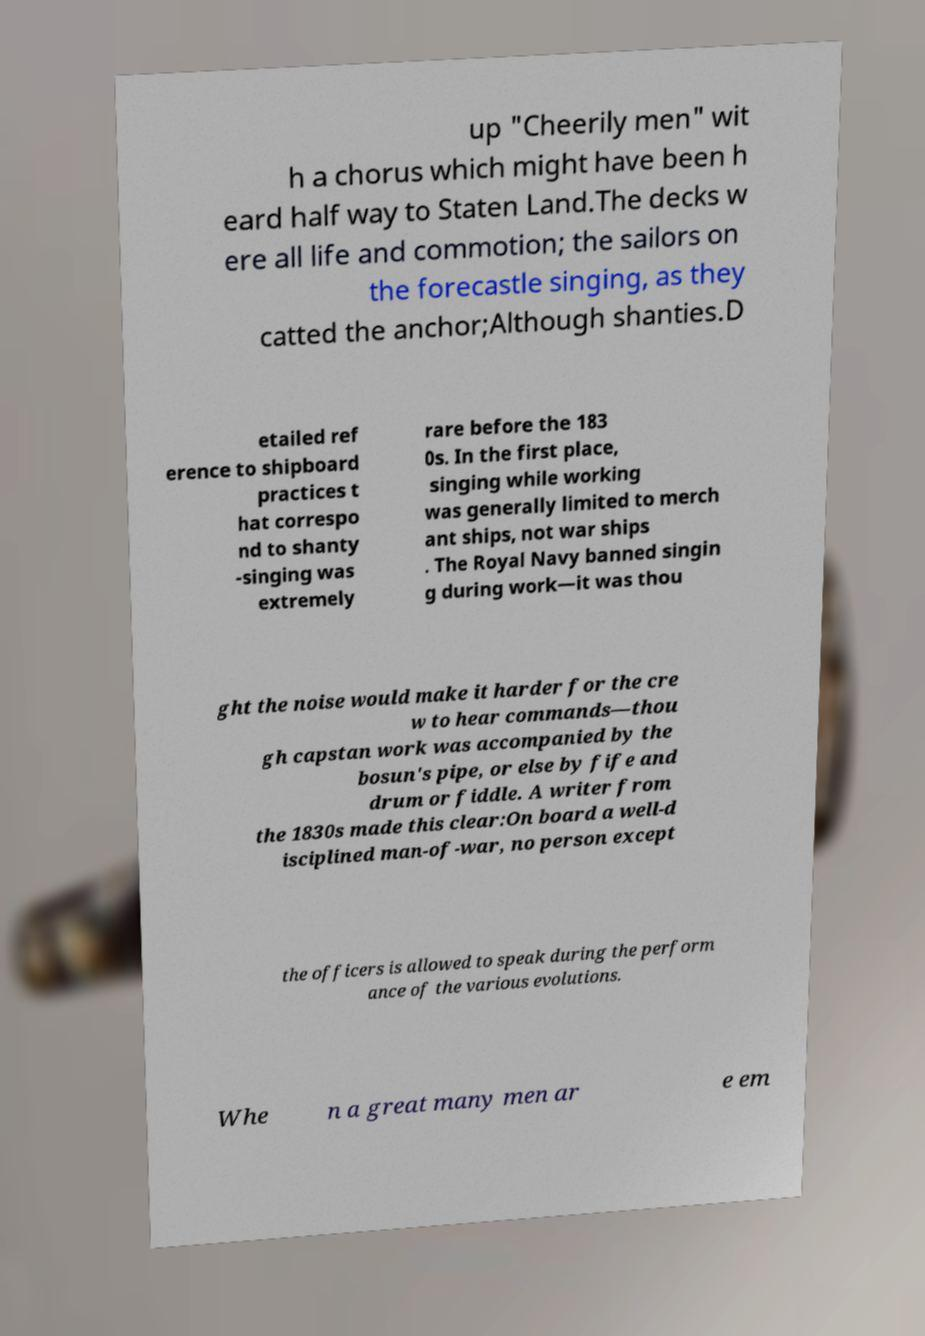Could you extract and type out the text from this image? up "Cheerily men" wit h a chorus which might have been h eard half way to Staten Land.The decks w ere all life and commotion; the sailors on the forecastle singing, as they catted the anchor;Although shanties.D etailed ref erence to shipboard practices t hat correspo nd to shanty -singing was extremely rare before the 183 0s. In the first place, singing while working was generally limited to merch ant ships, not war ships . The Royal Navy banned singin g during work—it was thou ght the noise would make it harder for the cre w to hear commands—thou gh capstan work was accompanied by the bosun's pipe, or else by fife and drum or fiddle. A writer from the 1830s made this clear:On board a well-d isciplined man-of-war, no person except the officers is allowed to speak during the perform ance of the various evolutions. Whe n a great many men ar e em 